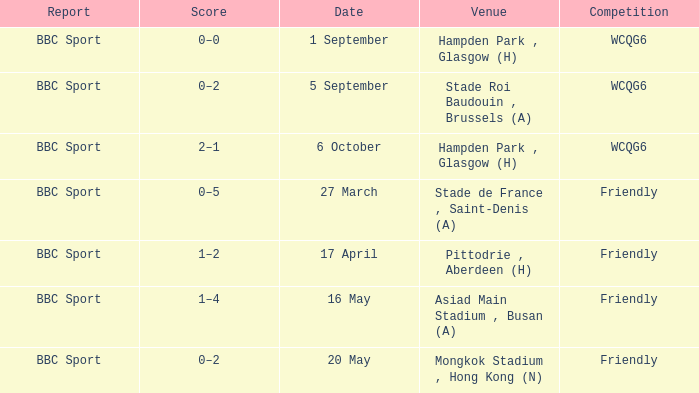Who reported the game played on 1 september? BBC Sport. 